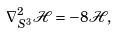<formula> <loc_0><loc_0><loc_500><loc_500>\nabla ^ { 2 } _ { S ^ { 3 } } \mathcal { H } = - 8 \mathcal { H } ,</formula> 